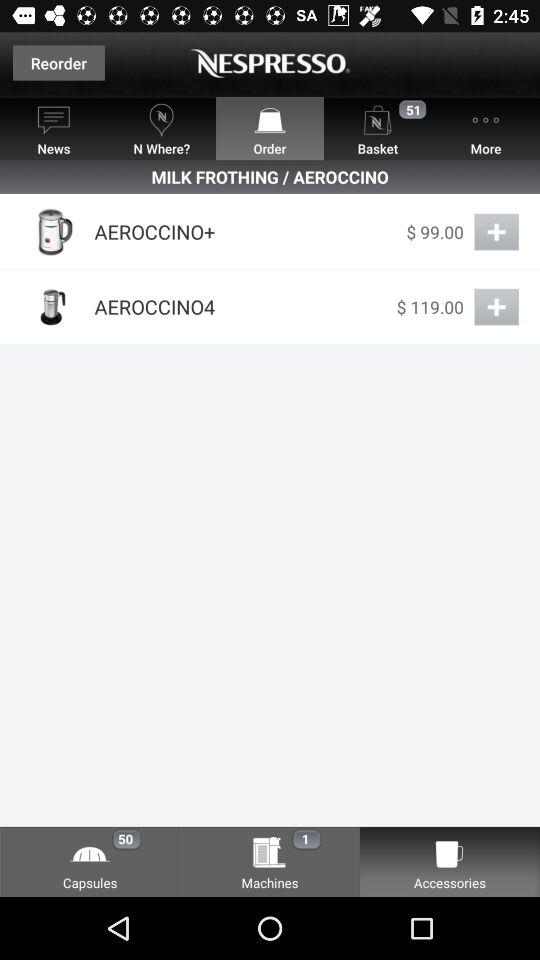What is the number of capsules? The number of capsules is 50. 